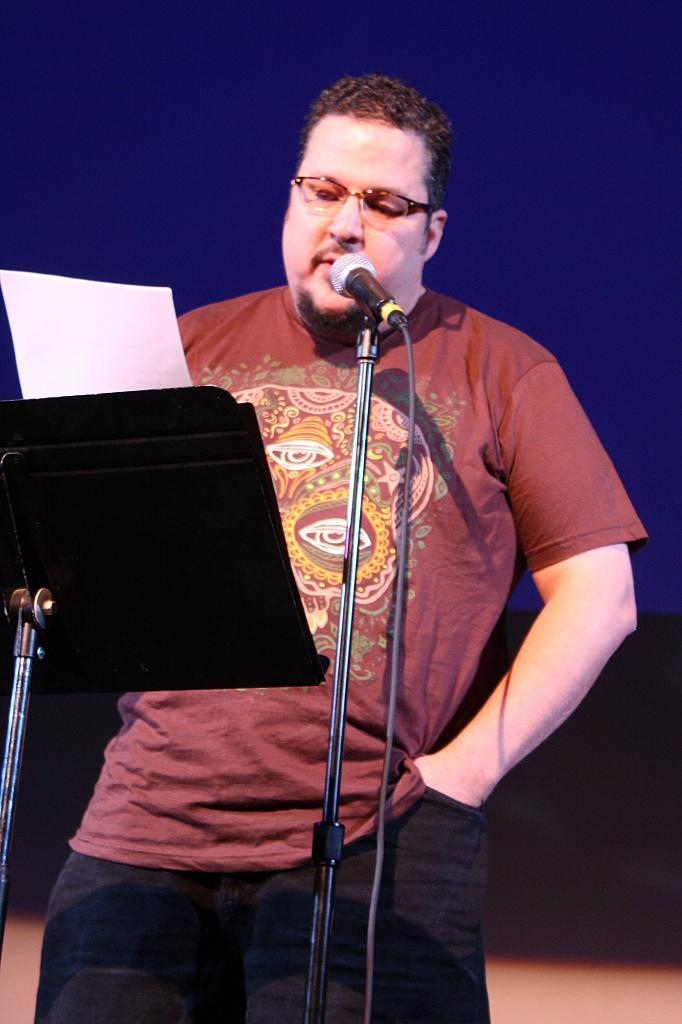What is the main subject in the foreground of the image? There is a man in the foreground of the image. What is the man doing in the image? The man is standing and reading some paper. What object is in front of the man? There is a microphone (mike) in front of the man. What type of metal is the man using to surprise the audience in the image? There is no metal or surprise element present in the image; the man is simply reading some paper with a microphone in front of him. 